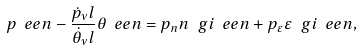Convert formula to latex. <formula><loc_0><loc_0><loc_500><loc_500>p _ { \ } e e n - \frac { \dot { p } _ { \nu } l } { \dot { \theta } _ { \nu } l } \theta _ { \ } e e n = p _ { n } n ^ { \ } g i _ { \ } e e n + p _ { \varepsilon } \varepsilon ^ { \ } g i _ { \ } e e n ,</formula> 